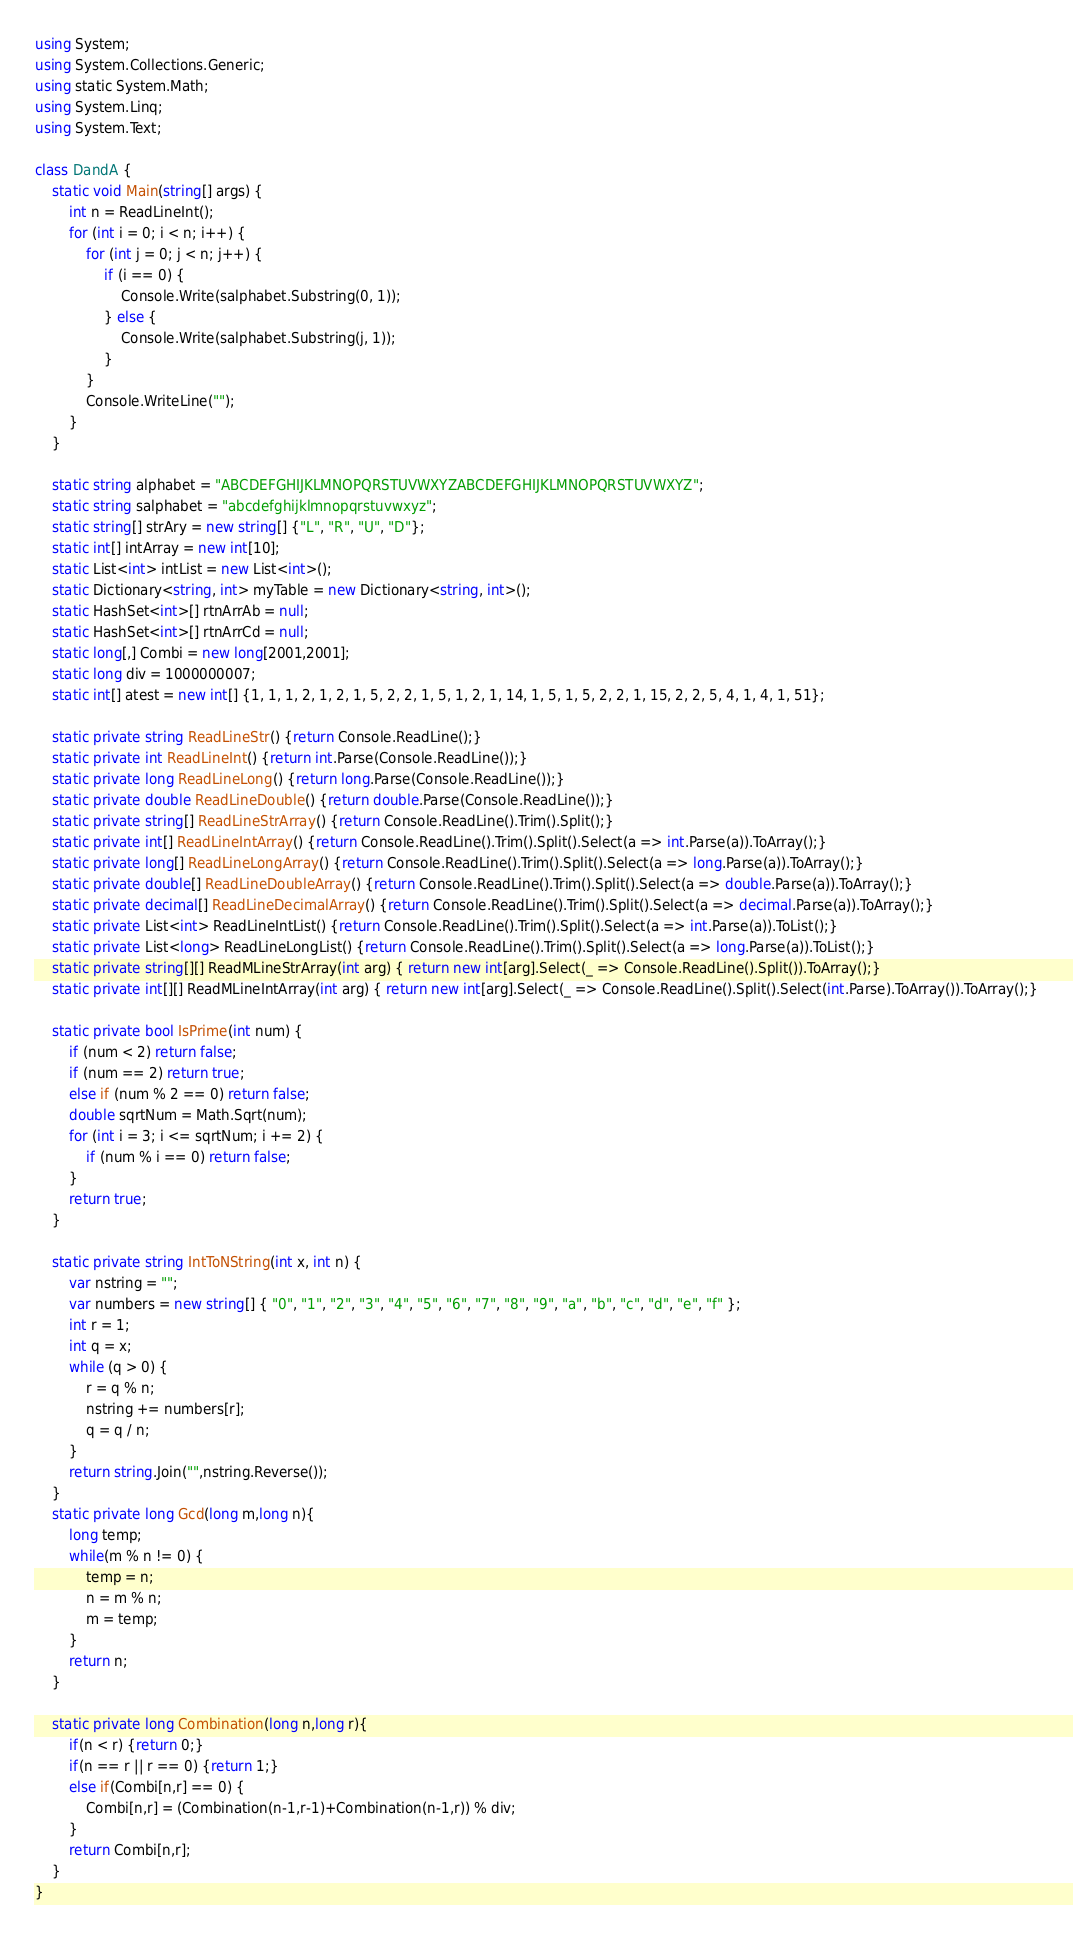<code> <loc_0><loc_0><loc_500><loc_500><_C#_>using System;
using System.Collections.Generic;
using static System.Math;
using System.Linq;
using System.Text;
 
class DandA {
    static void Main(string[] args) {
        int n = ReadLineInt();
        for (int i = 0; i < n; i++) {
            for (int j = 0; j < n; j++) {
                if (i == 0) {
                    Console.Write(salphabet.Substring(0, 1));
                } else {
                    Console.Write(salphabet.Substring(j, 1));
                }
            }
            Console.WriteLine("");
        }
    }
 
    static string alphabet = "ABCDEFGHIJKLMNOPQRSTUVWXYZABCDEFGHIJKLMNOPQRSTUVWXYZ";
    static string salphabet = "abcdefghijklmnopqrstuvwxyz";
    static string[] strAry = new string[] {"L", "R", "U", "D"};
    static int[] intArray = new int[10];
    static List<int> intList = new List<int>();
    static Dictionary<string, int> myTable = new Dictionary<string, int>();
    static HashSet<int>[] rtnArrAb = null;
    static HashSet<int>[] rtnArrCd = null;
    static long[,] Combi = new long[2001,2001];
    static long div = 1000000007;
    static int[] atest = new int[] {1, 1, 1, 2, 1, 2, 1, 5, 2, 2, 1, 5, 1, 2, 1, 14, 1, 5, 1, 5, 2, 2, 1, 15, 2, 2, 5, 4, 1, 4, 1, 51};
  
    static private string ReadLineStr() {return Console.ReadLine();}
    static private int ReadLineInt() {return int.Parse(Console.ReadLine());}
    static private long ReadLineLong() {return long.Parse(Console.ReadLine());}
    static private double ReadLineDouble() {return double.Parse(Console.ReadLine());}
    static private string[] ReadLineStrArray() {return Console.ReadLine().Trim().Split();}
    static private int[] ReadLineIntArray() {return Console.ReadLine().Trim().Split().Select(a => int.Parse(a)).ToArray();}
    static private long[] ReadLineLongArray() {return Console.ReadLine().Trim().Split().Select(a => long.Parse(a)).ToArray();}
    static private double[] ReadLineDoubleArray() {return Console.ReadLine().Trim().Split().Select(a => double.Parse(a)).ToArray();}
    static private decimal[] ReadLineDecimalArray() {return Console.ReadLine().Trim().Split().Select(a => decimal.Parse(a)).ToArray();}
    static private List<int> ReadLineIntList() {return Console.ReadLine().Trim().Split().Select(a => int.Parse(a)).ToList();}
    static private List<long> ReadLineLongList() {return Console.ReadLine().Trim().Split().Select(a => long.Parse(a)).ToList();}
    static private string[][] ReadMLineStrArray(int arg) { return new int[arg].Select(_ => Console.ReadLine().Split()).ToArray();}
    static private int[][] ReadMLineIntArray(int arg) { return new int[arg].Select(_ => Console.ReadLine().Split().Select(int.Parse).ToArray()).ToArray();}
 
    static private bool IsPrime(int num) {
        if (num < 2) return false;
        if (num == 2) return true;
        else if (num % 2 == 0) return false;
        double sqrtNum = Math.Sqrt(num);
        for (int i = 3; i <= sqrtNum; i += 2) {
            if (num % i == 0) return false;
        }
        return true;
    }
  
    static private string IntToNString(int x, int n) {
        var nstring = "";
        var numbers = new string[] { "0", "1", "2", "3", "4", "5", "6", "7", "8", "9", "a", "b", "c", "d", "e", "f" };
        int r = 1;
        int q = x;
        while (q > 0) {
            r = q % n;
            nstring += numbers[r];
            q = q / n;
        }
        return string.Join("",nstring.Reverse());
    }
    static private long Gcd(long m,long n){
        long temp;
        while(m % n != 0) {
            temp = n;
            n = m % n;
            m = temp;
        }
        return n;
    }
 
    static private long Combination(long n,long r){
        if(n < r) {return 0;}
        if(n == r || r == 0) {return 1;}
        else if(Combi[n,r] == 0) {
            Combi[n,r] = (Combination(n-1,r-1)+Combination(n-1,r)) % div;
        }
        return Combi[n,r];
    }
}</code> 